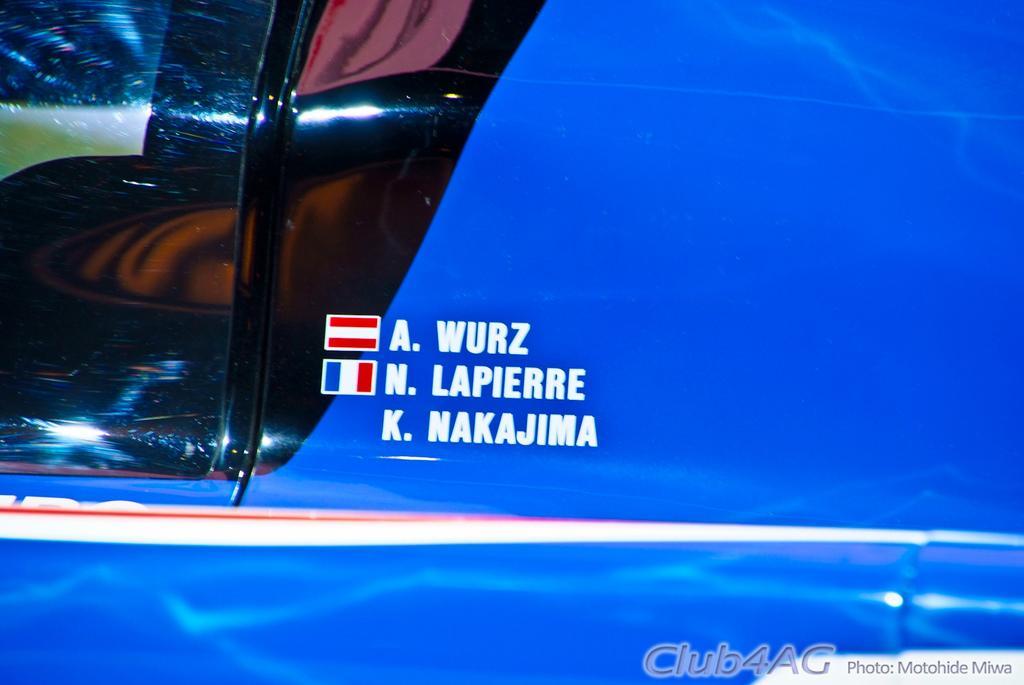Please provide a concise description of this image. In this picture we can see a vehicle with some text and flag symbols on it. 